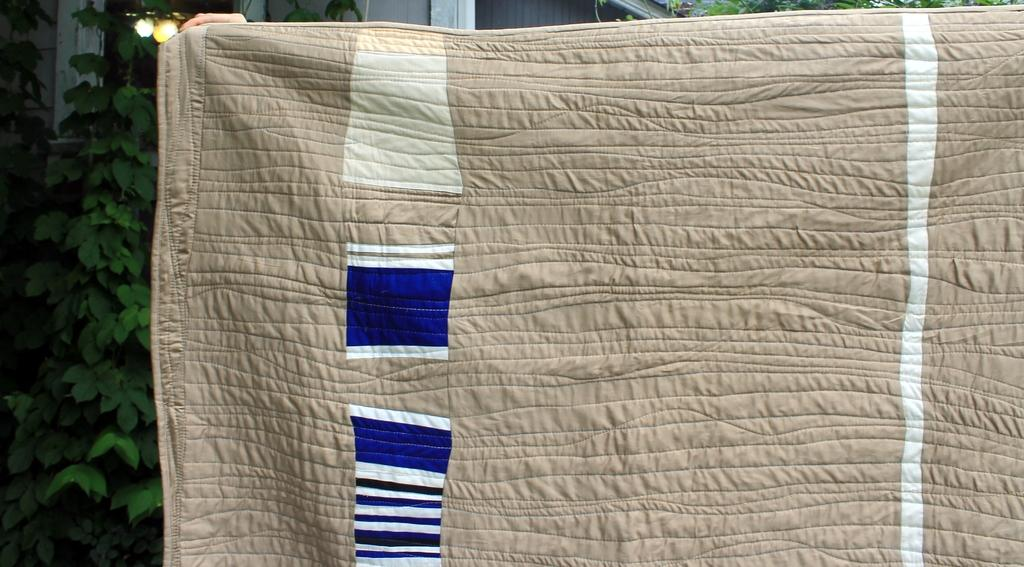What object is present in the image that might provide warmth or comfort? There is a blanket in the image. What can be seen in the background of the image? There are plants and a house in the background of the image. What type of brass instrument is being played by the person in the image? There is no person or brass instrument present in the image. Can you see the ear of the person in the image? There is no person present in the image, so it is not possible to see their ear. 